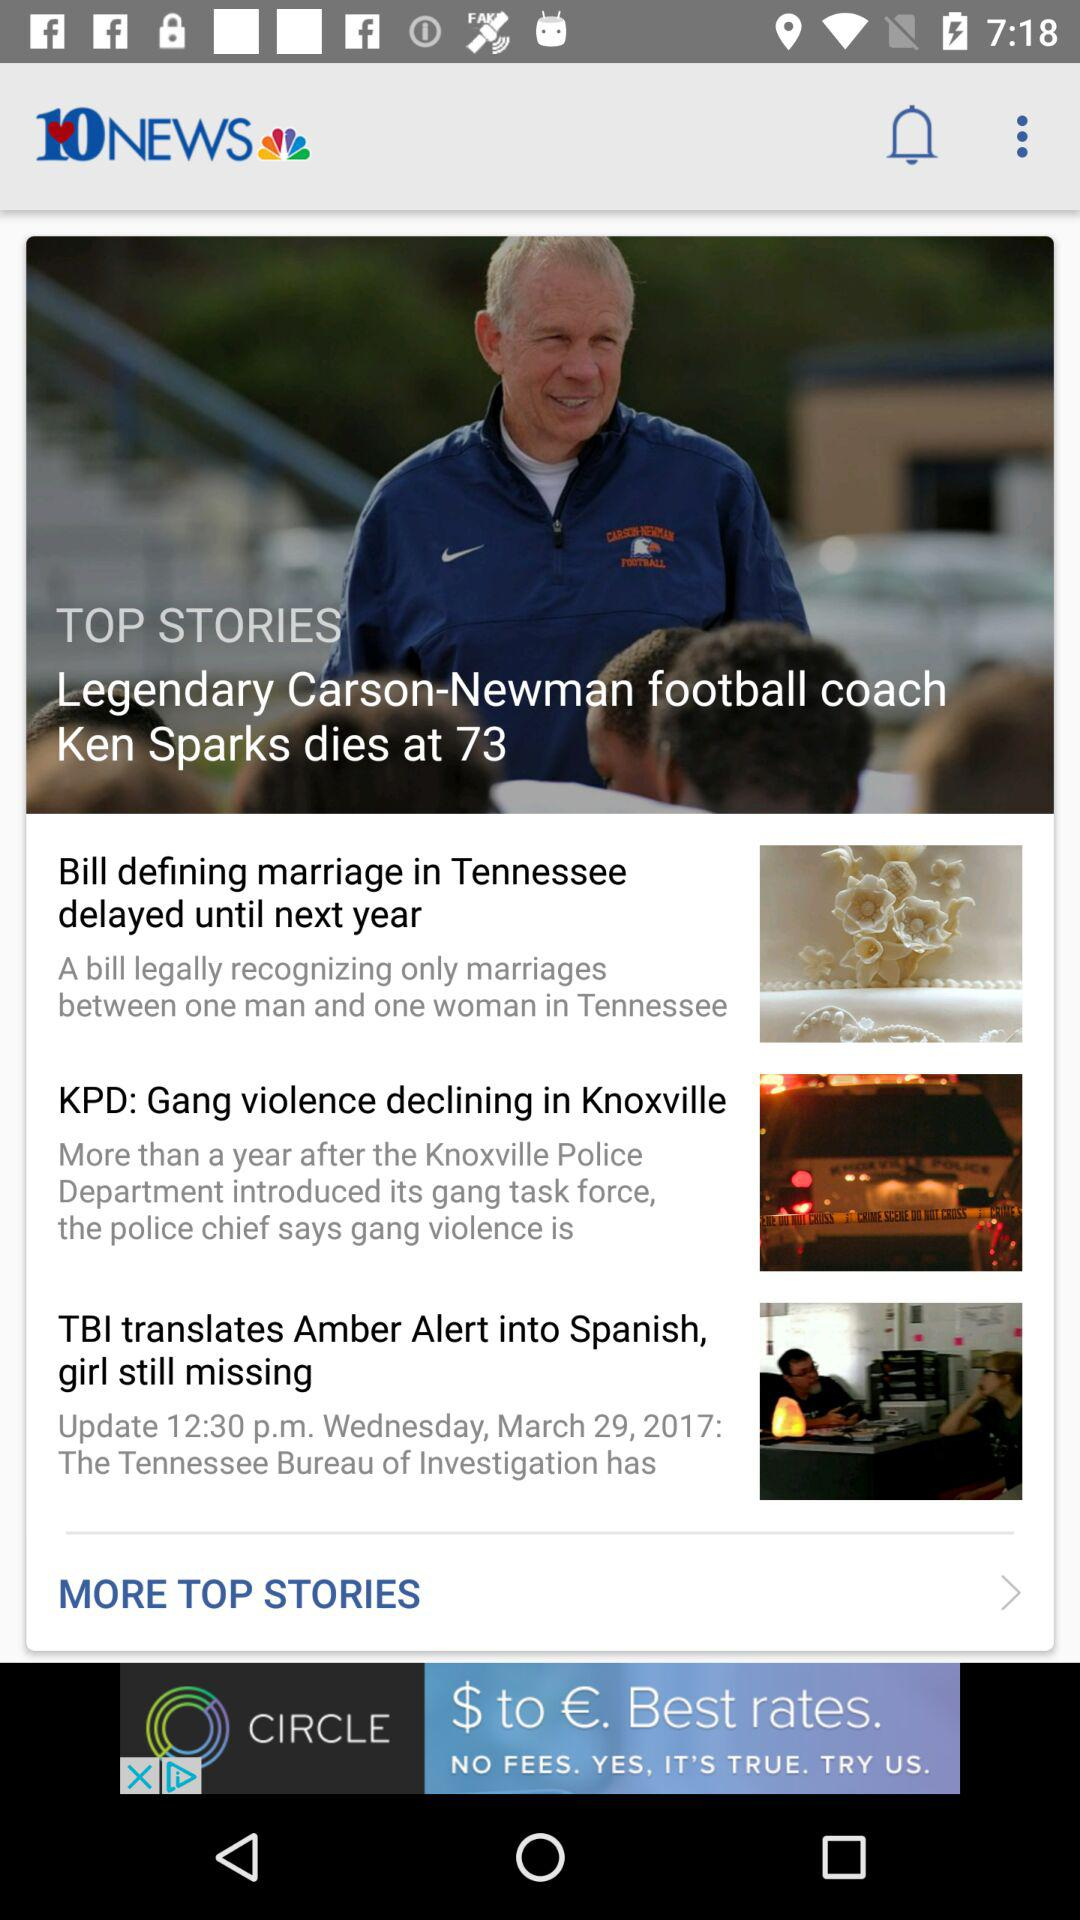At what age did Carson Newman die? Carson Newman dies at 73. 